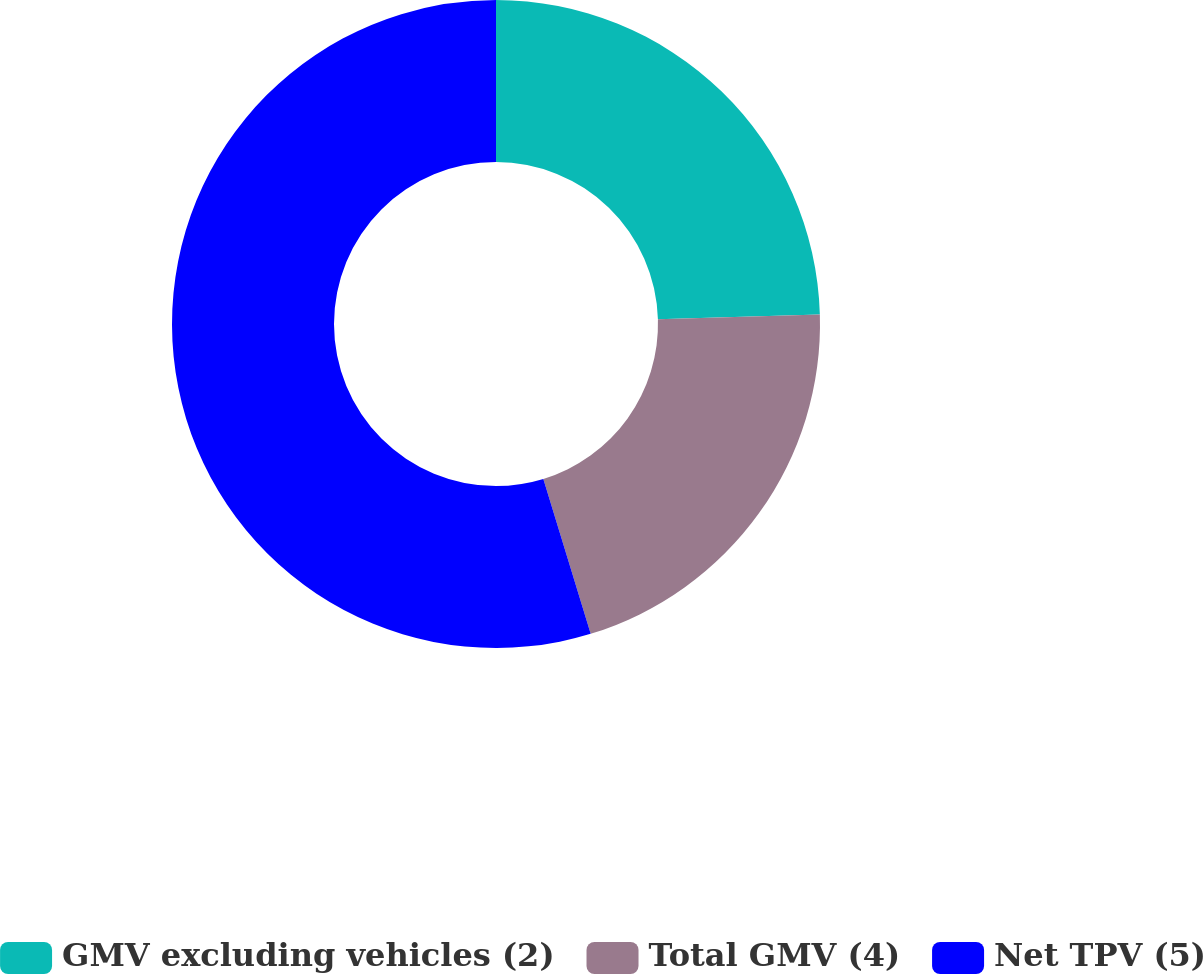Convert chart to OTSL. <chart><loc_0><loc_0><loc_500><loc_500><pie_chart><fcel>GMV excluding vehicles (2)<fcel>Total GMV (4)<fcel>Net TPV (5)<nl><fcel>24.53%<fcel>20.75%<fcel>54.72%<nl></chart> 